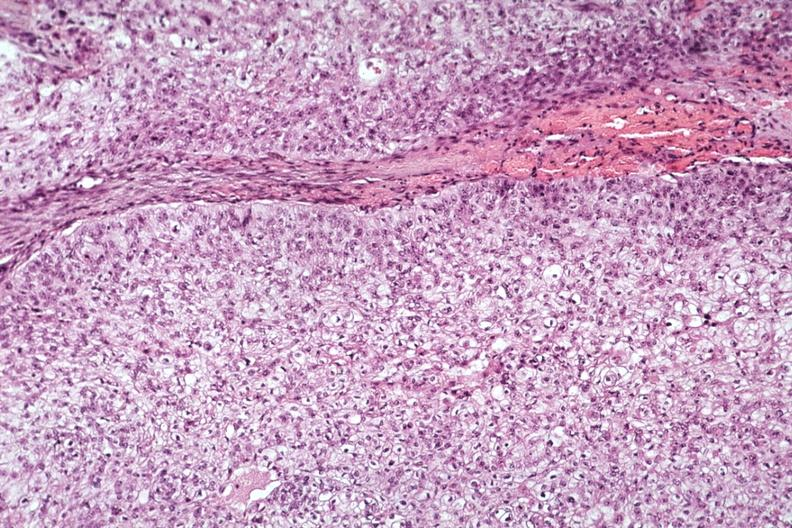s heart present?
Answer the question using a single word or phrase. No 